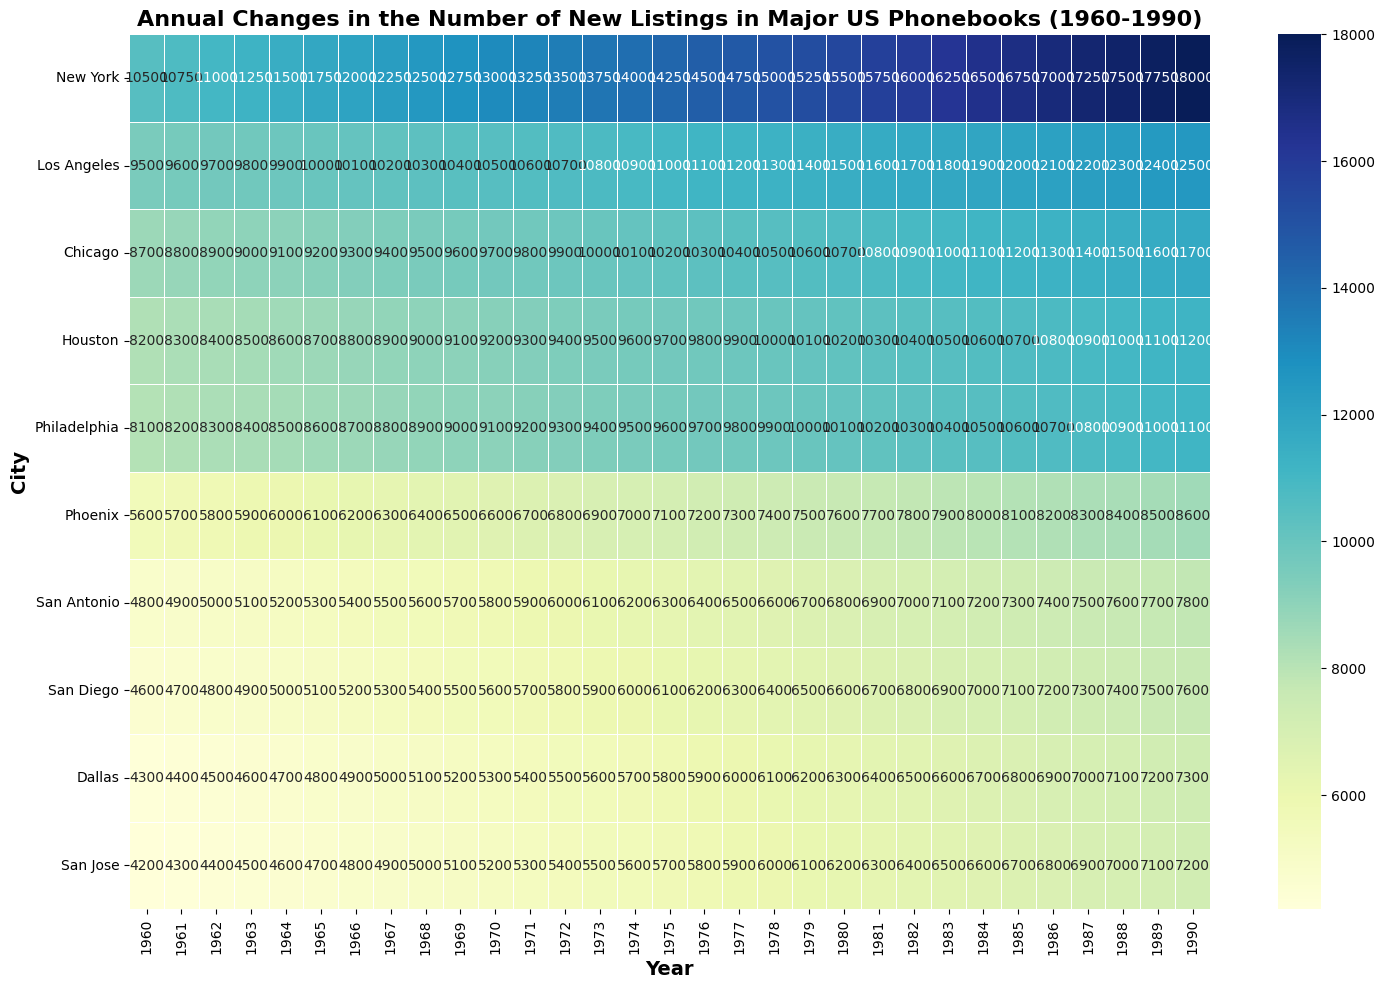What year had the most new listings in San Diego? Look for the highest number in the San Diego row and find the corresponding year at the top. The highest number is 7600 in 1990.
Answer: 1990 Which city had the highest number of new listings in 1970? Look at the column for 1970 and find the highest value among cities. The highest value is 13000, which corresponds to New York.
Answer: New York By how much did the number of new listings in Houston increase from 1965 to 1975? Subtract the number of new listings in Houston for 1965 (8700) from those in 1975 (9700). The difference is 9700 - 8700 = 1000.
Answer: 1000 Which cities had more than 10000 new listings consistently from 1980 to 1990? Look for cities with all values above 10000 for each year from 1980 to 1990. These cities are New York, Los Angeles, and Chicago.
Answer: New York, Los Angeles, Chicago What is the average number of new listings in Phoenix from 1983 to 1987? Sum the values for Phoenix from 1983 to 1987 (7900 + 8000 + 8100 + 8200 + 8300 = 40500), then divide by the number of years (40500 / 5 = 8100).
Answer: 8100 Compare the growth in new listings for Chicago and Philadelphia from 1960 to 1990. Which city had a higher increase? Subtract the 1960 values from the 1990 values for both cities. Chicago: 11700 - 8700 = 3000, Philadelphia: 11100 - 8100 = 3000. Both had the same increase.
Answer: Both had the same increase Which year saw the largest increase in new listings in New York compared to the previous year? Compare the differences between consecutive years for New York. The largest increase is between 1987 (17250) and 1988 (17500), which is 250.
Answer: 1988 What is the visual trend of new listings in Los Angeles from 1960 to 1990? The values for Los Angeles start from 9500 in 1960 and increase gradually each year, reaching 12500 in 1990, indicating a steady upward trend.
Answer: Steady upward trend In which decade did San Jose see the most significant growth in new listings? Compare the growth in San Jose by decades: 1960-1970 (5200 - 4200 = 1000), 1970-1980 (6200 - 5200 = 1000), 1980-1990 (7200 - 6200 = 1000). All decades have the same growth.
Answer: All decades had the same growth Is there any year where all ten cities had new phonebook listings between 4000 and 11000? Check each column to see if all values fall within the 4000 to 11000 range. 1960 is the year where all ten cities have values within this range.
Answer: 1960 